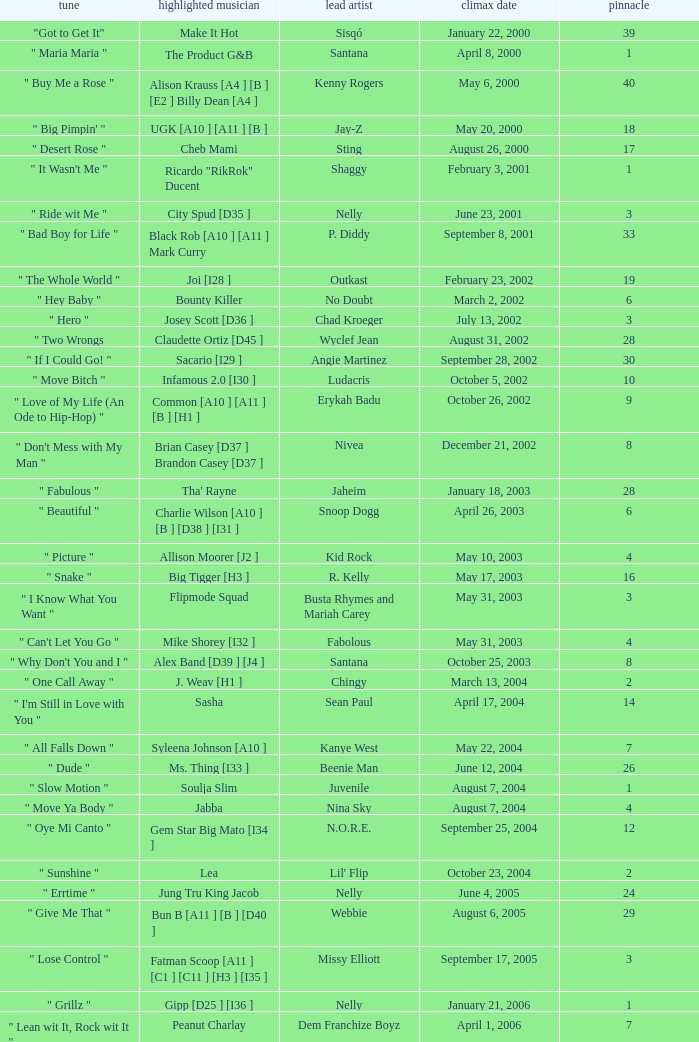What was the peak date of Kelis's song? August 6, 2006. Parse the table in full. {'header': ['tune', 'highlighted musician', 'lead artist', 'climax date', 'pinnacle'], 'rows': [['"Got to Get It"', 'Make It Hot', 'Sisqó', 'January 22, 2000', '39'], ['" Maria Maria "', 'The Product G&B', 'Santana', 'April 8, 2000', '1'], ['" Buy Me a Rose "', 'Alison Krauss [A4 ] [B ] [E2 ] Billy Dean [A4 ]', 'Kenny Rogers', 'May 6, 2000', '40'], ['" Big Pimpin\' "', 'UGK [A10 ] [A11 ] [B ]', 'Jay-Z', 'May 20, 2000', '18'], ['" Desert Rose "', 'Cheb Mami', 'Sting', 'August 26, 2000', '17'], ['" It Wasn\'t Me "', 'Ricardo "RikRok" Ducent', 'Shaggy', 'February 3, 2001', '1'], ['" Ride wit Me "', 'City Spud [D35 ]', 'Nelly', 'June 23, 2001', '3'], ['" Bad Boy for Life "', 'Black Rob [A10 ] [A11 ] Mark Curry', 'P. Diddy', 'September 8, 2001', '33'], ['" The Whole World "', 'Joi [I28 ]', 'Outkast', 'February 23, 2002', '19'], ['" Hey Baby "', 'Bounty Killer', 'No Doubt', 'March 2, 2002', '6'], ['" Hero "', 'Josey Scott [D36 ]', 'Chad Kroeger', 'July 13, 2002', '3'], ['" Two Wrongs', 'Claudette Ortiz [D45 ]', 'Wyclef Jean', 'August 31, 2002', '28'], ['" If I Could Go! "', 'Sacario [I29 ]', 'Angie Martinez', 'September 28, 2002', '30'], ['" Move Bitch "', 'Infamous 2.0 [I30 ]', 'Ludacris', 'October 5, 2002', '10'], ['" Love of My Life (An Ode to Hip-Hop) "', 'Common [A10 ] [A11 ] [B ] [H1 ]', 'Erykah Badu', 'October 26, 2002', '9'], ['" Don\'t Mess with My Man "', 'Brian Casey [D37 ] Brandon Casey [D37 ]', 'Nivea', 'December 21, 2002', '8'], ['" Fabulous "', "Tha' Rayne", 'Jaheim', 'January 18, 2003', '28'], ['" Beautiful "', 'Charlie Wilson [A10 ] [B ] [D38 ] [I31 ]', 'Snoop Dogg', 'April 26, 2003', '6'], ['" Picture "', 'Allison Moorer [J2 ]', 'Kid Rock', 'May 10, 2003', '4'], ['" Snake "', 'Big Tigger [H3 ]', 'R. Kelly', 'May 17, 2003', '16'], ['" I Know What You Want "', 'Flipmode Squad', 'Busta Rhymes and Mariah Carey', 'May 31, 2003', '3'], ['" Can\'t Let You Go "', 'Mike Shorey [I32 ]', 'Fabolous', 'May 31, 2003', '4'], ['" Why Don\'t You and I "', 'Alex Band [D39 ] [J4 ]', 'Santana', 'October 25, 2003', '8'], ['" One Call Away "', 'J. Weav [H1 ]', 'Chingy', 'March 13, 2004', '2'], ['" I\'m Still in Love with You "', 'Sasha', 'Sean Paul', 'April 17, 2004', '14'], ['" All Falls Down "', 'Syleena Johnson [A10 ]', 'Kanye West', 'May 22, 2004', '7'], ['" Dude "', 'Ms. Thing [I33 ]', 'Beenie Man', 'June 12, 2004', '26'], ['" Slow Motion "', 'Soulja Slim', 'Juvenile', 'August 7, 2004', '1'], ['" Move Ya Body "', 'Jabba', 'Nina Sky', 'August 7, 2004', '4'], ['" Oye Mi Canto "', 'Gem Star Big Mato [I34 ]', 'N.O.R.E.', 'September 25, 2004', '12'], ['" Sunshine "', 'Lea', "Lil' Flip", 'October 23, 2004', '2'], ['" Errtime "', 'Jung Tru King Jacob', 'Nelly', 'June 4, 2005', '24'], ['" Give Me That "', 'Bun B [A11 ] [B ] [D40 ]', 'Webbie', 'August 6, 2005', '29'], ['" Lose Control "', 'Fatman Scoop [A11 ] [C1 ] [C11 ] [H3 ] [I35 ]', 'Missy Elliott', 'September 17, 2005', '3'], ['" Grillz "', 'Gipp [D25 ] [I36 ]', 'Nelly', 'January 21, 2006', '1'], ['" Lean wit It, Rock wit It "', 'Peanut Charlay', 'Dem Franchize Boyz', 'April 1, 2006', '7'], ['" Tell Me When to Go "', 'Keak da Sneak [D41 ]', 'E-40', 'April 1, 2006', '35'], ['" Bossy "', 'Too $hort [A10 ] [A11 ] [A12 ] [B ]', 'Kelis', 'August 6, 2006', '16'], ['" I Know You See It "', 'Brandy "Ms. B" Hambrick', 'Yung Joc', 'September 30, 2006', '17'], ['" S.E.X. "', 'LaLa Brown', 'Lyfe Jennings', 'October 21, 2006', '37'], ['" You Don\'t Know "', 'Ca$his [I37 ]', 'Eminem', 'December 23, 2006', '12'], ['" The River "', 'M. Shadows [D42 ] Synyster Gates [D42 ]', 'Good Charlotte', 'April 14, 2007', '39'], ['" Wipe Me Down " (Remix)', 'Foxx [I38 ]', 'Lil Boosie', 'July 14, 2007', '38'], ['" Soulja Girl "', 'i15', "Soulja Boy Tell 'Em", 'December 8, 2007', '32'], ['" Sweetest Girl (Dollar Bill) "', 'Niia [I39 ]', 'Wyclef Jean', 'January 5, 2008', '9'], ['" Independent "', 'Lil Phat [I40 ]', 'Webbie', 'March 8, 2008', '9'], ['" Superstar "', 'Matthew Santos', 'Lupe Fiasco', 'March 22, 2008', '10'], ['" Lollipop "', 'Static Major [D43 ] [G1 ]', 'Lil Wayne', 'May 3, 2008', '1'], ['" Lolli Lolli (Pop That Body) "', 'Project Pat [D44 ] Young D Superpower', 'Three 6 Mafia', 'June 14, 2008', '18'], ['" The Business "', 'Casha', 'Yung Berg', 'September 6, 2008', '33'], ['" Put It on Ya "', 'Chris J', 'Plies', 'January 3, 2009', '31'], ['" Sugar "', 'Wynter [A5 ] [C1 ] [C6 ] [C10 ]', 'Flo Rida', 'May 16, 2009', '5'], ['" Good Girls Go Bad "', 'Leighton Meester [H1 ]', 'Cobra Starship', 'August 22, 2009', '7']]} 